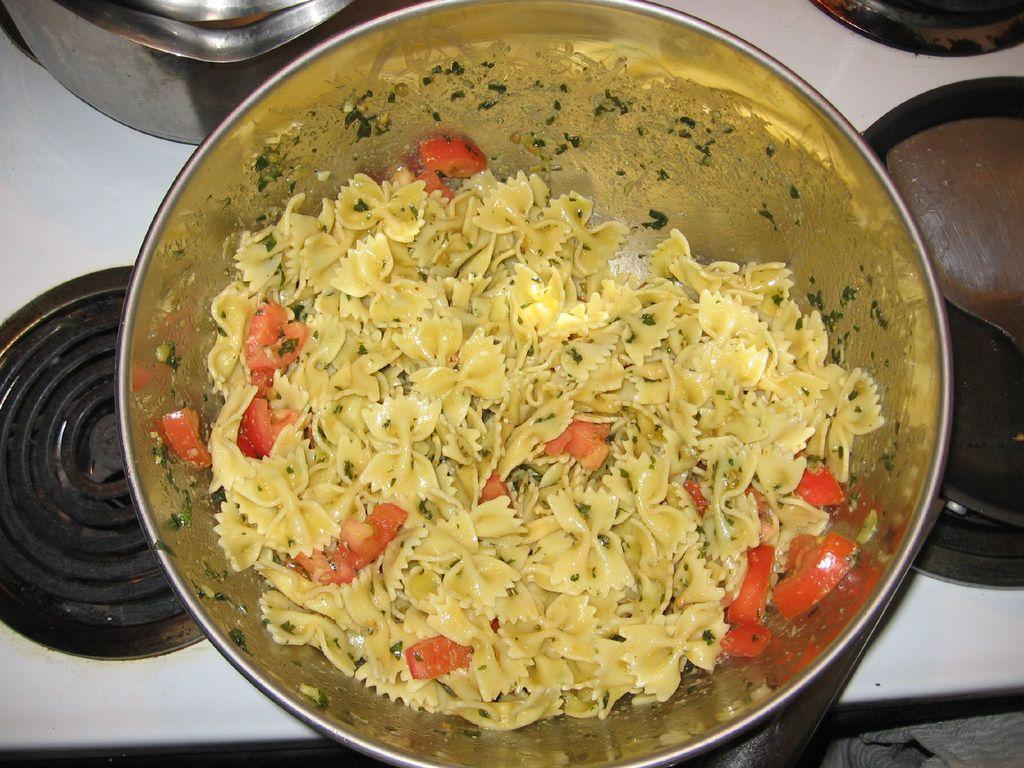What is present in the image? There is a bowl in the image. What is inside the bowl? The bowl is filled with food items. What sound can be heard coming from the bowl in the image? There is no sound coming from the bowl in the image, as it is a still image and cannot produce sound. 